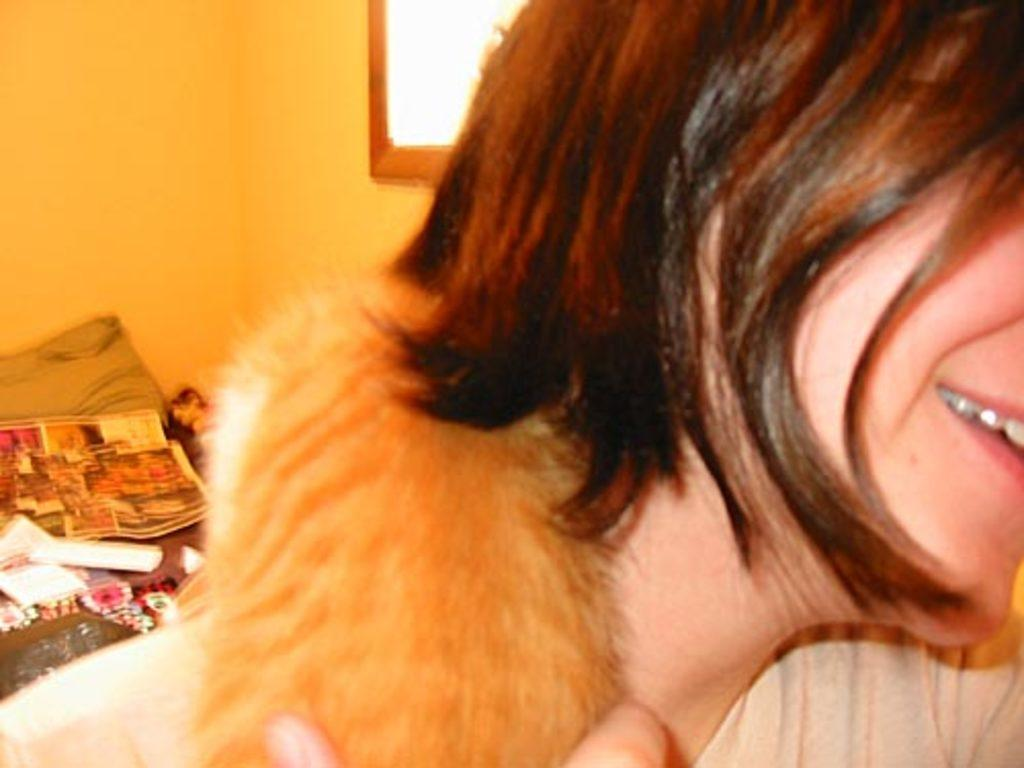Who or what is present in the image? There is a person in the image. What can be seen on the walls in the image? There are posters in the image. What type of furniture is visible in the image? There is a pillow in the image. What else can be seen in the image besides the person and the pillow? There are objects in the image. What is visible in the background of the image? There is a wall and a mirror in the background of the image. What type of art can be seen on the person's boot in the image? There is no boot present in the image, and therefore no art can be seen on it. 